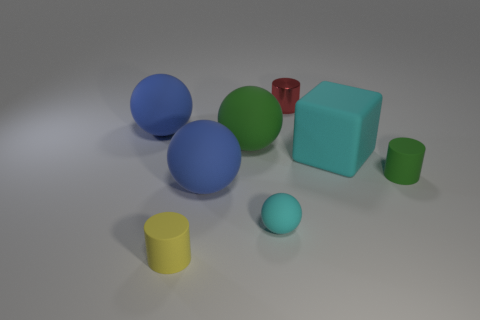There is another matte thing that is the same shape as the tiny yellow thing; what color is it?
Keep it short and to the point. Green. Do the cyan matte sphere in front of the big cyan cube and the blue object left of the yellow matte cylinder have the same size?
Your response must be concise. No. The big rubber thing that is the same color as the tiny rubber sphere is what shape?
Your response must be concise. Cube. Are there any spheres of the same color as the rubber block?
Your response must be concise. Yes. Is there any other thing that is the same color as the matte cube?
Your response must be concise. Yes. Are there more small objects that are behind the cyan matte sphere than big cyan things?
Provide a short and direct response. Yes. There is a green thing that is on the right side of the tiny red metallic thing; is it the same shape as the large cyan thing?
Provide a succinct answer. No. Is there any other thing that is the same material as the small red object?
Provide a short and direct response. No. What number of objects are either small purple metal balls or cylinders to the left of the red shiny thing?
Your response must be concise. 1. There is a object that is both to the left of the small green cylinder and to the right of the red shiny cylinder; what is its size?
Give a very brief answer. Large. 